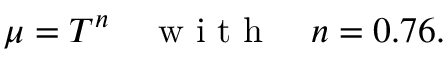Convert formula to latex. <formula><loc_0><loc_0><loc_500><loc_500>\mu = T ^ { n } \quad w i t h \quad n = 0 . 7 6 .</formula> 